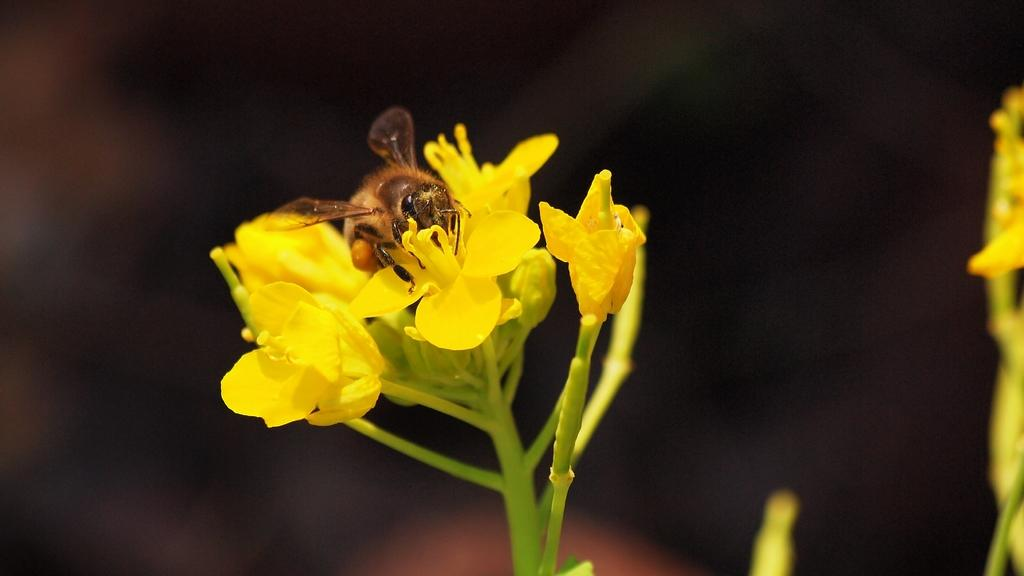What is the main subject of the image? There is an insect in the image. Where is the insect located? The insect is sitting on a yellow flower. What type of plant does the flower belong to? The flower is on a plant. Can you describe the background of the image? The background of the image is blurred. What type of reaction can be seen in the image? There is no reaction visible in the image; it features an insect sitting on a yellow flower. Can you tell me how many planets are visible in the image? There are no planets visible in the image; it features an insect sitting on a yellow flower on a plant. 